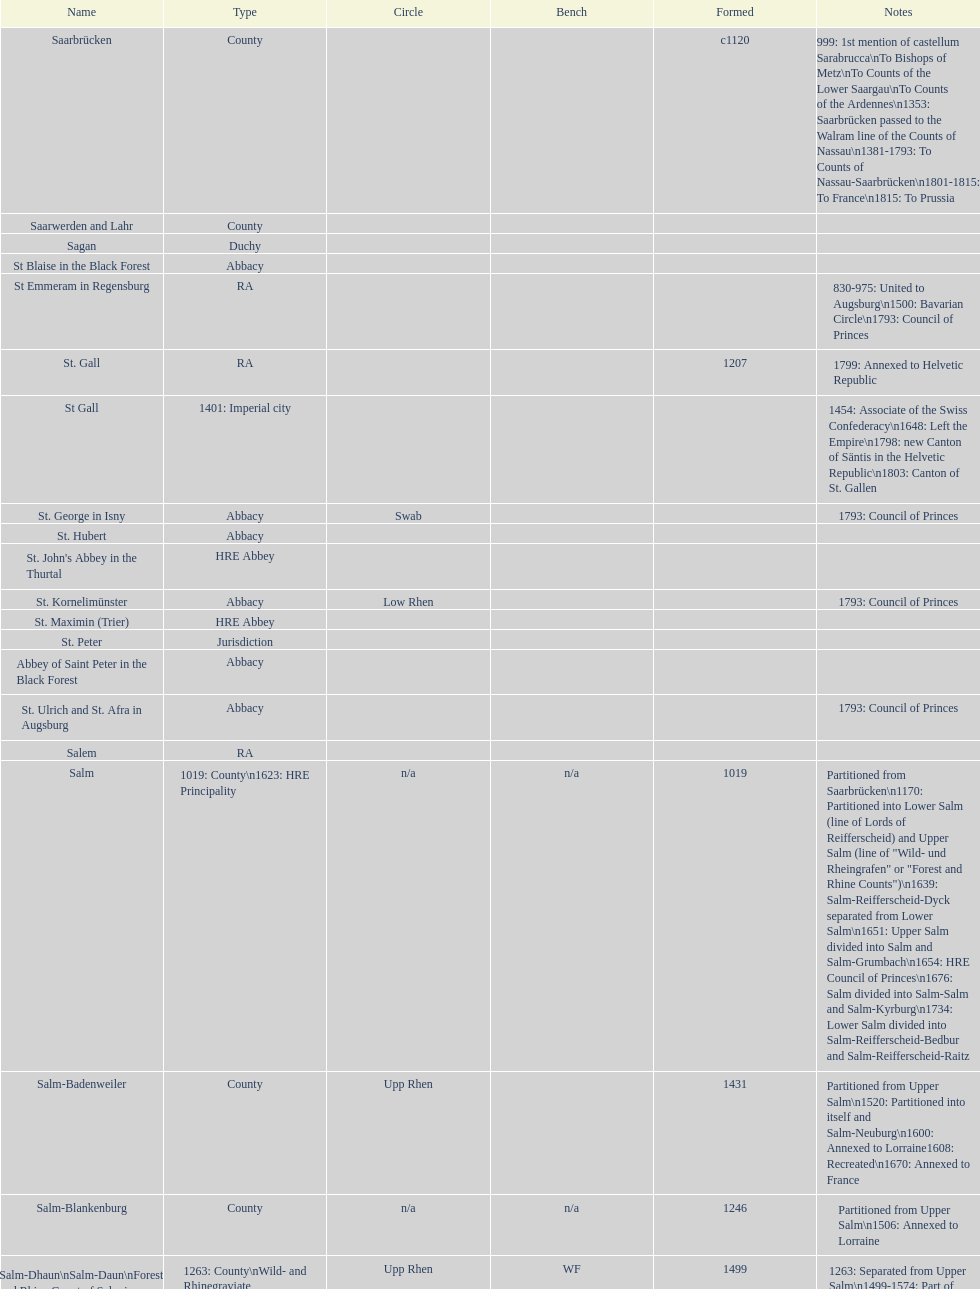Which bench is the most prevalent? PR. 